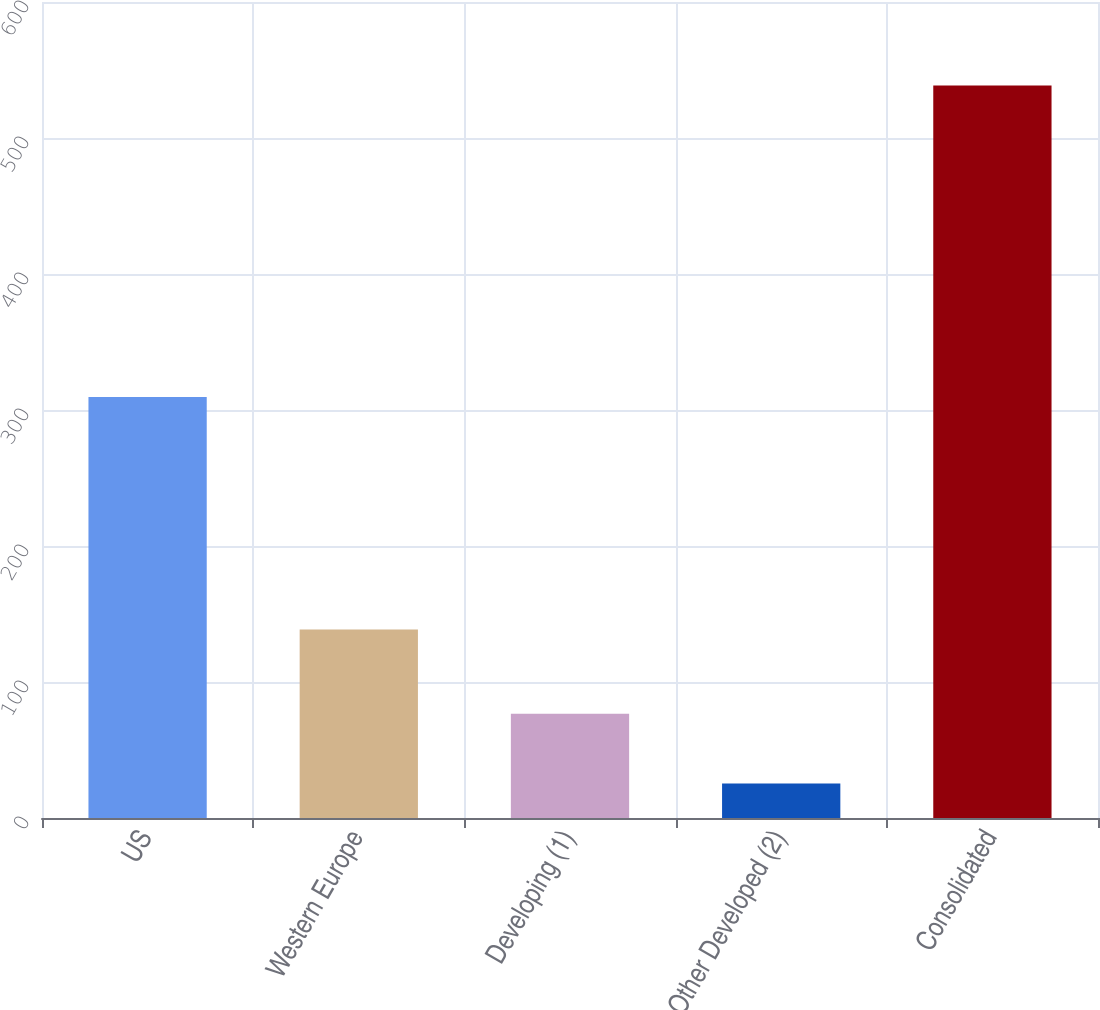<chart> <loc_0><loc_0><loc_500><loc_500><bar_chart><fcel>US<fcel>Western Europe<fcel>Developing (1)<fcel>Other Developed (2)<fcel>Consolidated<nl><fcel>309.5<fcel>138.6<fcel>76.63<fcel>25.3<fcel>538.6<nl></chart> 